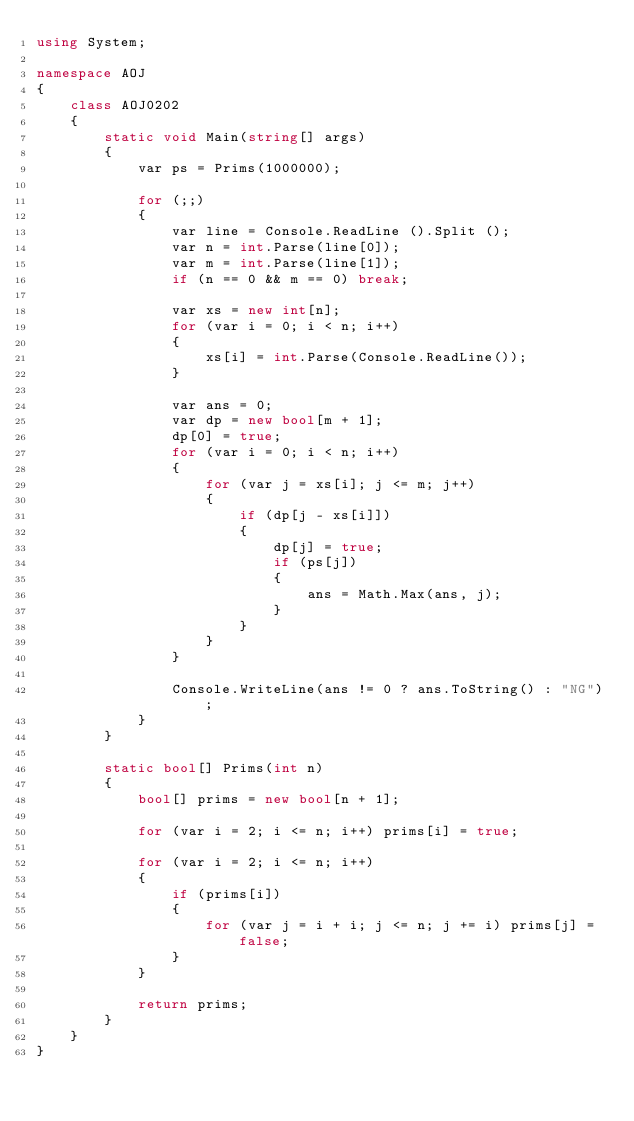<code> <loc_0><loc_0><loc_500><loc_500><_C#_>using System;

namespace AOJ
{
    class AOJ0202
    {
        static void Main(string[] args)
        {
            var ps = Prims(1000000);

            for (;;)
            {
                var line = Console.ReadLine ().Split ();
                var n = int.Parse(line[0]);
                var m = int.Parse(line[1]);
                if (n == 0 && m == 0) break;

                var xs = new int[n];
                for (var i = 0; i < n; i++)
                {
                    xs[i] = int.Parse(Console.ReadLine());
                }

                var ans = 0;
                var dp = new bool[m + 1];
                dp[0] = true;
                for (var i = 0; i < n; i++)
                {
                    for (var j = xs[i]; j <= m; j++)
                    {
                        if (dp[j - xs[i]])
                        {
                            dp[j] = true;
                            if (ps[j])
                            {
                                ans = Math.Max(ans, j);
                            }
                        }
                    }
                }

                Console.WriteLine(ans != 0 ? ans.ToString() : "NG");
            }
        }

        static bool[] Prims(int n)
        {
            bool[] prims = new bool[n + 1];

            for (var i = 2; i <= n; i++) prims[i] = true;

            for (var i = 2; i <= n; i++)
            {
                if (prims[i])
                {
                    for (var j = i + i; j <= n; j += i) prims[j] = false;
                }
            }

            return prims;
        }
    }
}</code> 